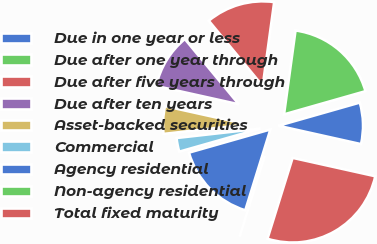<chart> <loc_0><loc_0><loc_500><loc_500><pie_chart><fcel>Due in one year or less<fcel>Due after one year through<fcel>Due after five years through<fcel>Due after ten years<fcel>Asset-backed securities<fcel>Commercial<fcel>Agency residential<fcel>Non-agency residential<fcel>Total fixed maturity<nl><fcel>7.9%<fcel>18.42%<fcel>13.16%<fcel>10.53%<fcel>5.26%<fcel>2.63%<fcel>15.79%<fcel>0.0%<fcel>26.31%<nl></chart> 